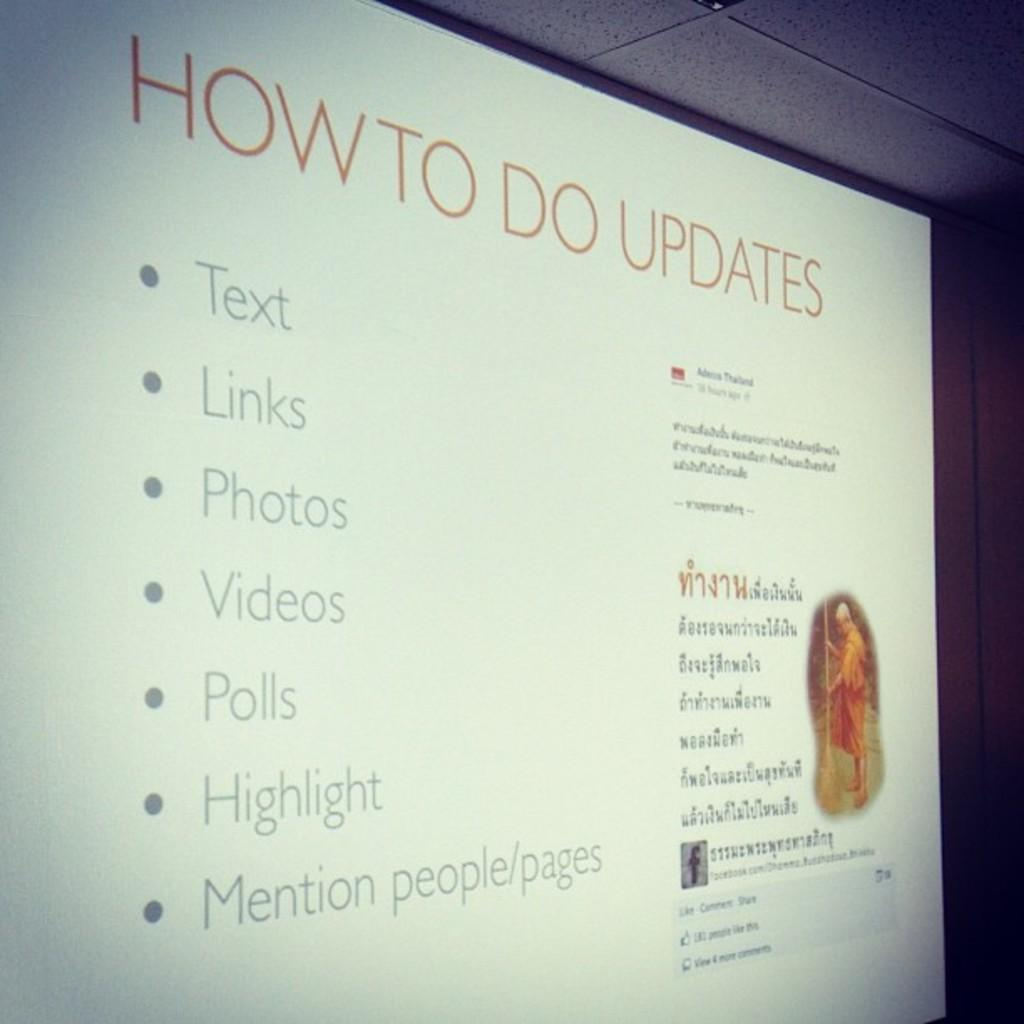<image>
Present a compact description of the photo's key features. Someone is doing a presentation on how to updates. 